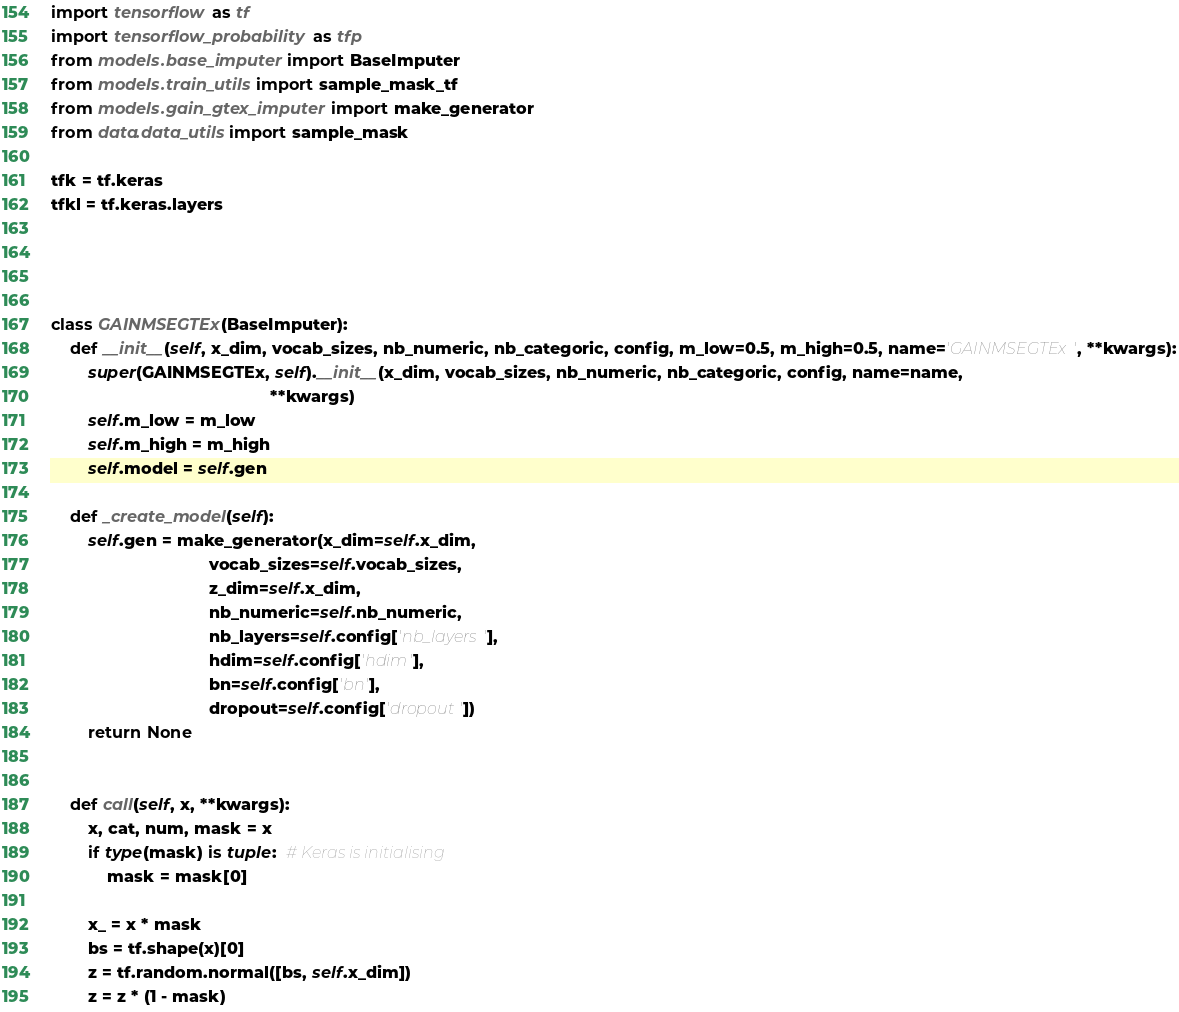Convert code to text. <code><loc_0><loc_0><loc_500><loc_500><_Python_>import tensorflow as tf
import tensorflow_probability as tfp
from models.base_imputer import BaseImputer
from models.train_utils import sample_mask_tf
from models.gain_gtex_imputer import make_generator
from data.data_utils import sample_mask

tfk = tf.keras
tfkl = tf.keras.layers




class GAINMSEGTEx(BaseImputer):
    def __init__(self, x_dim, vocab_sizes, nb_numeric, nb_categoric, config, m_low=0.5, m_high=0.5, name='GAINMSEGTEx', **kwargs):
        super(GAINMSEGTEx, self).__init__(x_dim, vocab_sizes, nb_numeric, nb_categoric, config, name=name,
                                               **kwargs)
        self.m_low = m_low
        self.m_high = m_high
        self.model = self.gen

    def _create_model(self):
        self.gen = make_generator(x_dim=self.x_dim,
                                  vocab_sizes=self.vocab_sizes,
                                  z_dim=self.x_dim,
                                  nb_numeric=self.nb_numeric,
                                  nb_layers=self.config['nb_layers'],
                                  hdim=self.config['hdim'],
                                  bn=self.config['bn'],
                                  dropout=self.config['dropout'])
        return None


    def call(self, x, **kwargs):
        x, cat, num, mask = x
        if type(mask) is tuple:  # Keras is initialising
            mask = mask[0]

        x_ = x * mask
        bs = tf.shape(x)[0]
        z = tf.random.normal([bs, self.x_dim])
        z = z * (1 - mask)</code> 